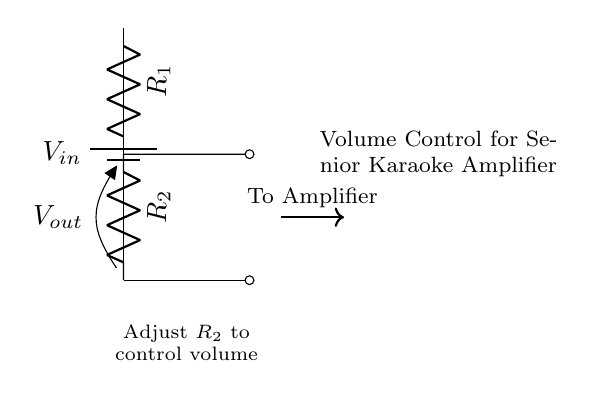What is the input voltage? The input voltage, denoted as V_in, is represented at the top of the circuit connected to the battery symbol.
Answer: V_in What do R_1 and R_2 represent? R_1 and R_2 are both resistors; R_1 is the upper resistor and R_2 is the lower resistor in this voltage divider setup.
Answer: Resistors What is V_out? V_out is the output voltage across R_2, which is indicated in the circuit diagram next to R_2.
Answer: Output voltage How does adjusting R_2 affect the circuit? Adjusting R_2 changes the resistance in the voltage divider, which in turn alters the output voltage V_out, affecting the volume level.
Answer: Alters volume What type of circuit is this? This circuit is a voltage divider, specifically designed to control audio volume by adjusting the output voltage for an amplifier.
Answer: Voltage divider What is the purpose of this circuit? The purpose of the circuit is to serve as a volume control for a homemade amplifier used in senior karaoke events.
Answer: Volume control 